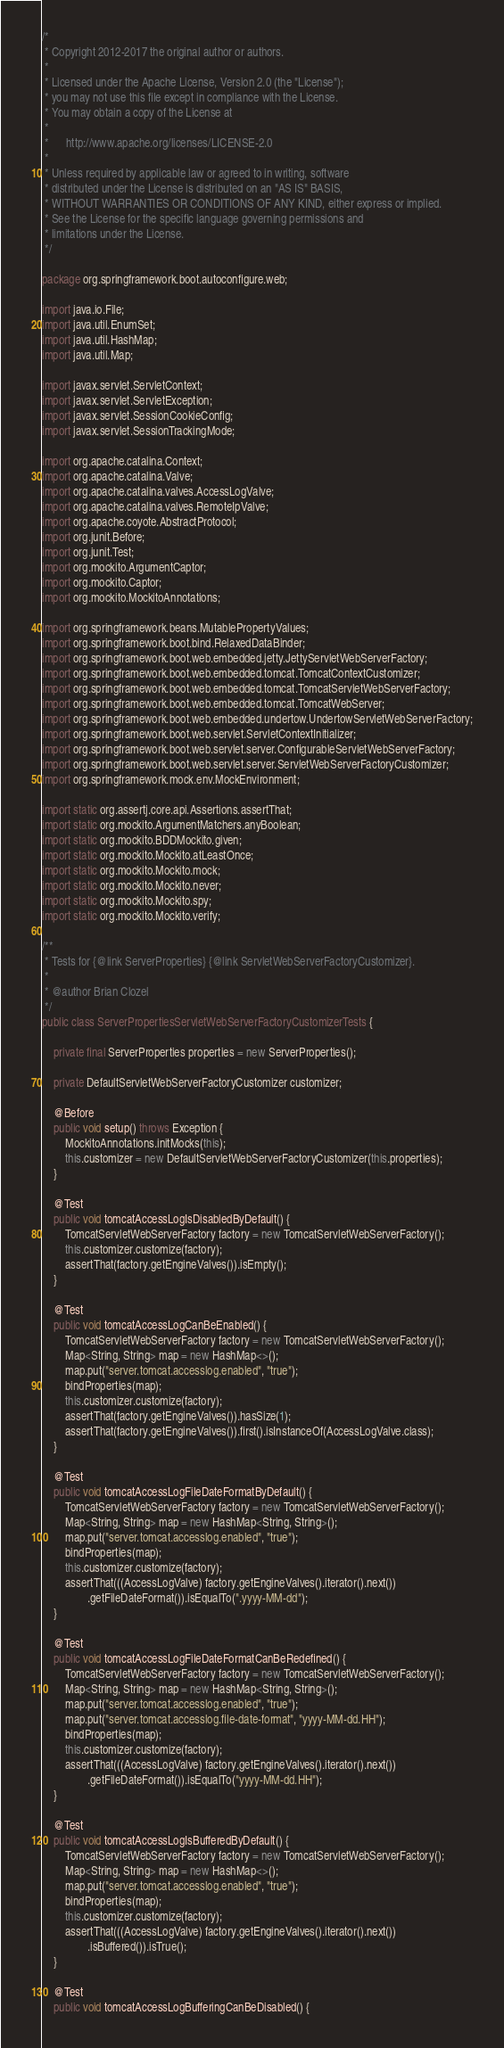Convert code to text. <code><loc_0><loc_0><loc_500><loc_500><_Java_>/*
 * Copyright 2012-2017 the original author or authors.
 *
 * Licensed under the Apache License, Version 2.0 (the "License");
 * you may not use this file except in compliance with the License.
 * You may obtain a copy of the License at
 *
 *      http://www.apache.org/licenses/LICENSE-2.0
 *
 * Unless required by applicable law or agreed to in writing, software
 * distributed under the License is distributed on an "AS IS" BASIS,
 * WITHOUT WARRANTIES OR CONDITIONS OF ANY KIND, either express or implied.
 * See the License for the specific language governing permissions and
 * limitations under the License.
 */

package org.springframework.boot.autoconfigure.web;

import java.io.File;
import java.util.EnumSet;
import java.util.HashMap;
import java.util.Map;

import javax.servlet.ServletContext;
import javax.servlet.ServletException;
import javax.servlet.SessionCookieConfig;
import javax.servlet.SessionTrackingMode;

import org.apache.catalina.Context;
import org.apache.catalina.Valve;
import org.apache.catalina.valves.AccessLogValve;
import org.apache.catalina.valves.RemoteIpValve;
import org.apache.coyote.AbstractProtocol;
import org.junit.Before;
import org.junit.Test;
import org.mockito.ArgumentCaptor;
import org.mockito.Captor;
import org.mockito.MockitoAnnotations;

import org.springframework.beans.MutablePropertyValues;
import org.springframework.boot.bind.RelaxedDataBinder;
import org.springframework.boot.web.embedded.jetty.JettyServletWebServerFactory;
import org.springframework.boot.web.embedded.tomcat.TomcatContextCustomizer;
import org.springframework.boot.web.embedded.tomcat.TomcatServletWebServerFactory;
import org.springframework.boot.web.embedded.tomcat.TomcatWebServer;
import org.springframework.boot.web.embedded.undertow.UndertowServletWebServerFactory;
import org.springframework.boot.web.servlet.ServletContextInitializer;
import org.springframework.boot.web.servlet.server.ConfigurableServletWebServerFactory;
import org.springframework.boot.web.servlet.server.ServletWebServerFactoryCustomizer;
import org.springframework.mock.env.MockEnvironment;

import static org.assertj.core.api.Assertions.assertThat;
import static org.mockito.ArgumentMatchers.anyBoolean;
import static org.mockito.BDDMockito.given;
import static org.mockito.Mockito.atLeastOnce;
import static org.mockito.Mockito.mock;
import static org.mockito.Mockito.never;
import static org.mockito.Mockito.spy;
import static org.mockito.Mockito.verify;

/**
 * Tests for {@link ServerProperties} {@link ServletWebServerFactoryCustomizer}.
 *
 * @author Brian Clozel
 */
public class ServerPropertiesServletWebServerFactoryCustomizerTests {

	private final ServerProperties properties = new ServerProperties();

	private DefaultServletWebServerFactoryCustomizer customizer;

	@Before
	public void setup() throws Exception {
		MockitoAnnotations.initMocks(this);
		this.customizer = new DefaultServletWebServerFactoryCustomizer(this.properties);
	}

	@Test
	public void tomcatAccessLogIsDisabledByDefault() {
		TomcatServletWebServerFactory factory = new TomcatServletWebServerFactory();
		this.customizer.customize(factory);
		assertThat(factory.getEngineValves()).isEmpty();
	}

	@Test
	public void tomcatAccessLogCanBeEnabled() {
		TomcatServletWebServerFactory factory = new TomcatServletWebServerFactory();
		Map<String, String> map = new HashMap<>();
		map.put("server.tomcat.accesslog.enabled", "true");
		bindProperties(map);
		this.customizer.customize(factory);
		assertThat(factory.getEngineValves()).hasSize(1);
		assertThat(factory.getEngineValves()).first().isInstanceOf(AccessLogValve.class);
	}

	@Test
	public void tomcatAccessLogFileDateFormatByDefault() {
		TomcatServletWebServerFactory factory = new TomcatServletWebServerFactory();
		Map<String, String> map = new HashMap<String, String>();
		map.put("server.tomcat.accesslog.enabled", "true");
		bindProperties(map);
		this.customizer.customize(factory);
		assertThat(((AccessLogValve) factory.getEngineValves().iterator().next())
				.getFileDateFormat()).isEqualTo(".yyyy-MM-dd");
	}

	@Test
	public void tomcatAccessLogFileDateFormatCanBeRedefined() {
		TomcatServletWebServerFactory factory = new TomcatServletWebServerFactory();
		Map<String, String> map = new HashMap<String, String>();
		map.put("server.tomcat.accesslog.enabled", "true");
		map.put("server.tomcat.accesslog.file-date-format", "yyyy-MM-dd.HH");
		bindProperties(map);
		this.customizer.customize(factory);
		assertThat(((AccessLogValve) factory.getEngineValves().iterator().next())
				.getFileDateFormat()).isEqualTo("yyyy-MM-dd.HH");
	}

	@Test
	public void tomcatAccessLogIsBufferedByDefault() {
		TomcatServletWebServerFactory factory = new TomcatServletWebServerFactory();
		Map<String, String> map = new HashMap<>();
		map.put("server.tomcat.accesslog.enabled", "true");
		bindProperties(map);
		this.customizer.customize(factory);
		assertThat(((AccessLogValve) factory.getEngineValves().iterator().next())
				.isBuffered()).isTrue();
	}

	@Test
	public void tomcatAccessLogBufferingCanBeDisabled() {</code> 